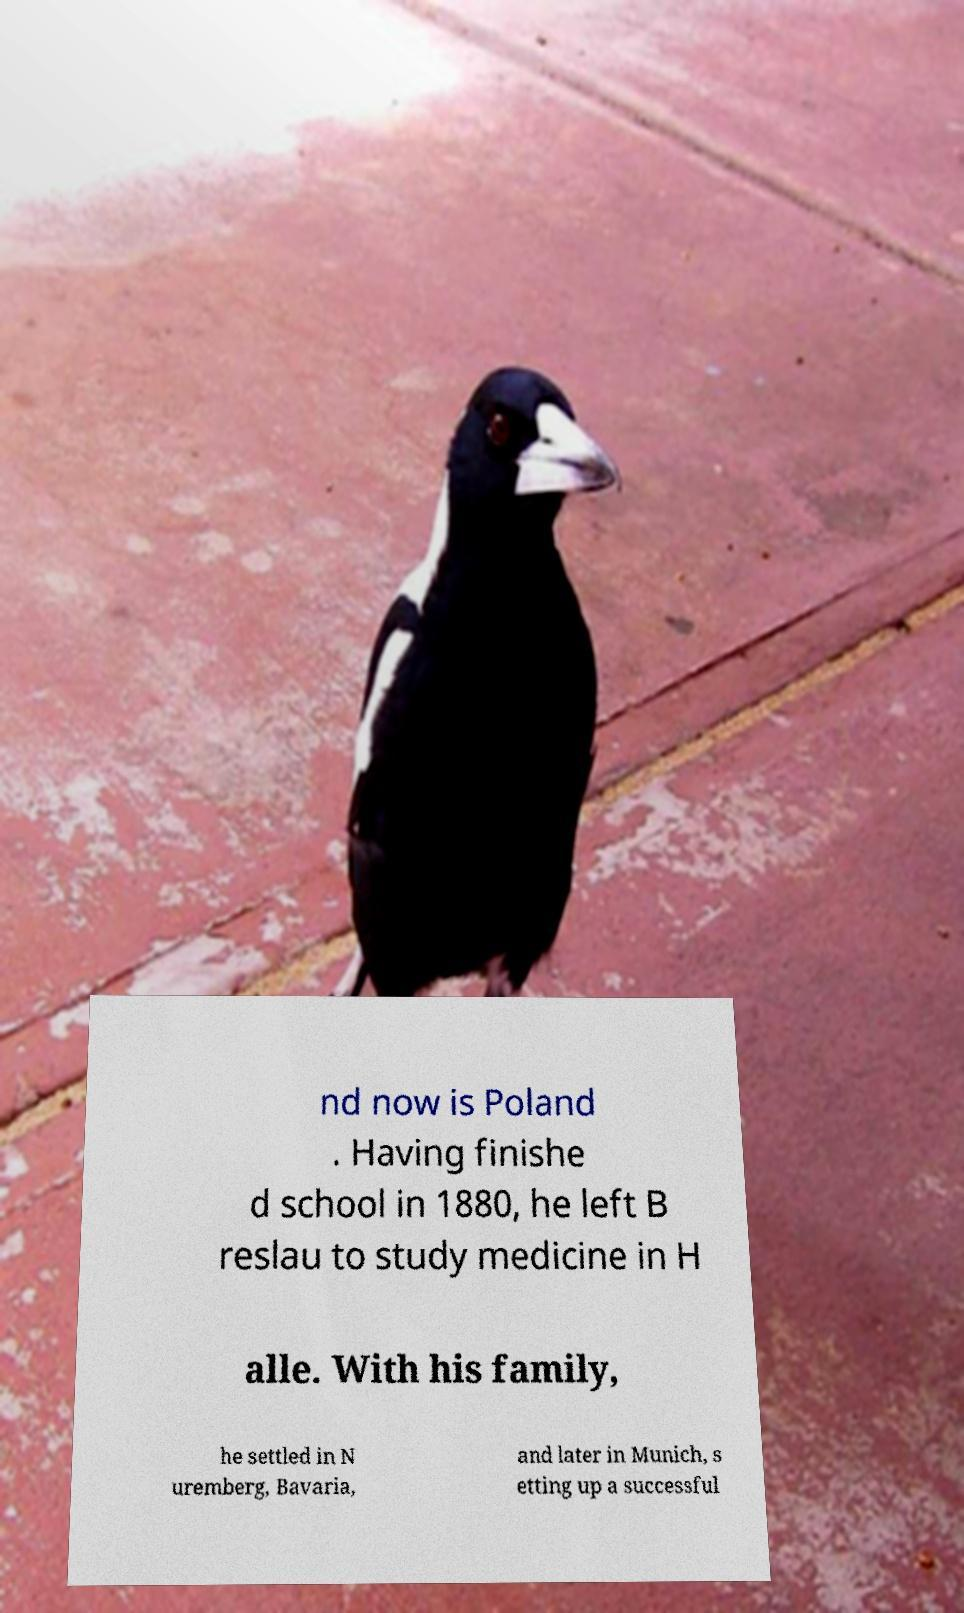Could you assist in decoding the text presented in this image and type it out clearly? nd now is Poland . Having finishe d school in 1880, he left B reslau to study medicine in H alle. With his family, he settled in N uremberg, Bavaria, and later in Munich, s etting up a successful 